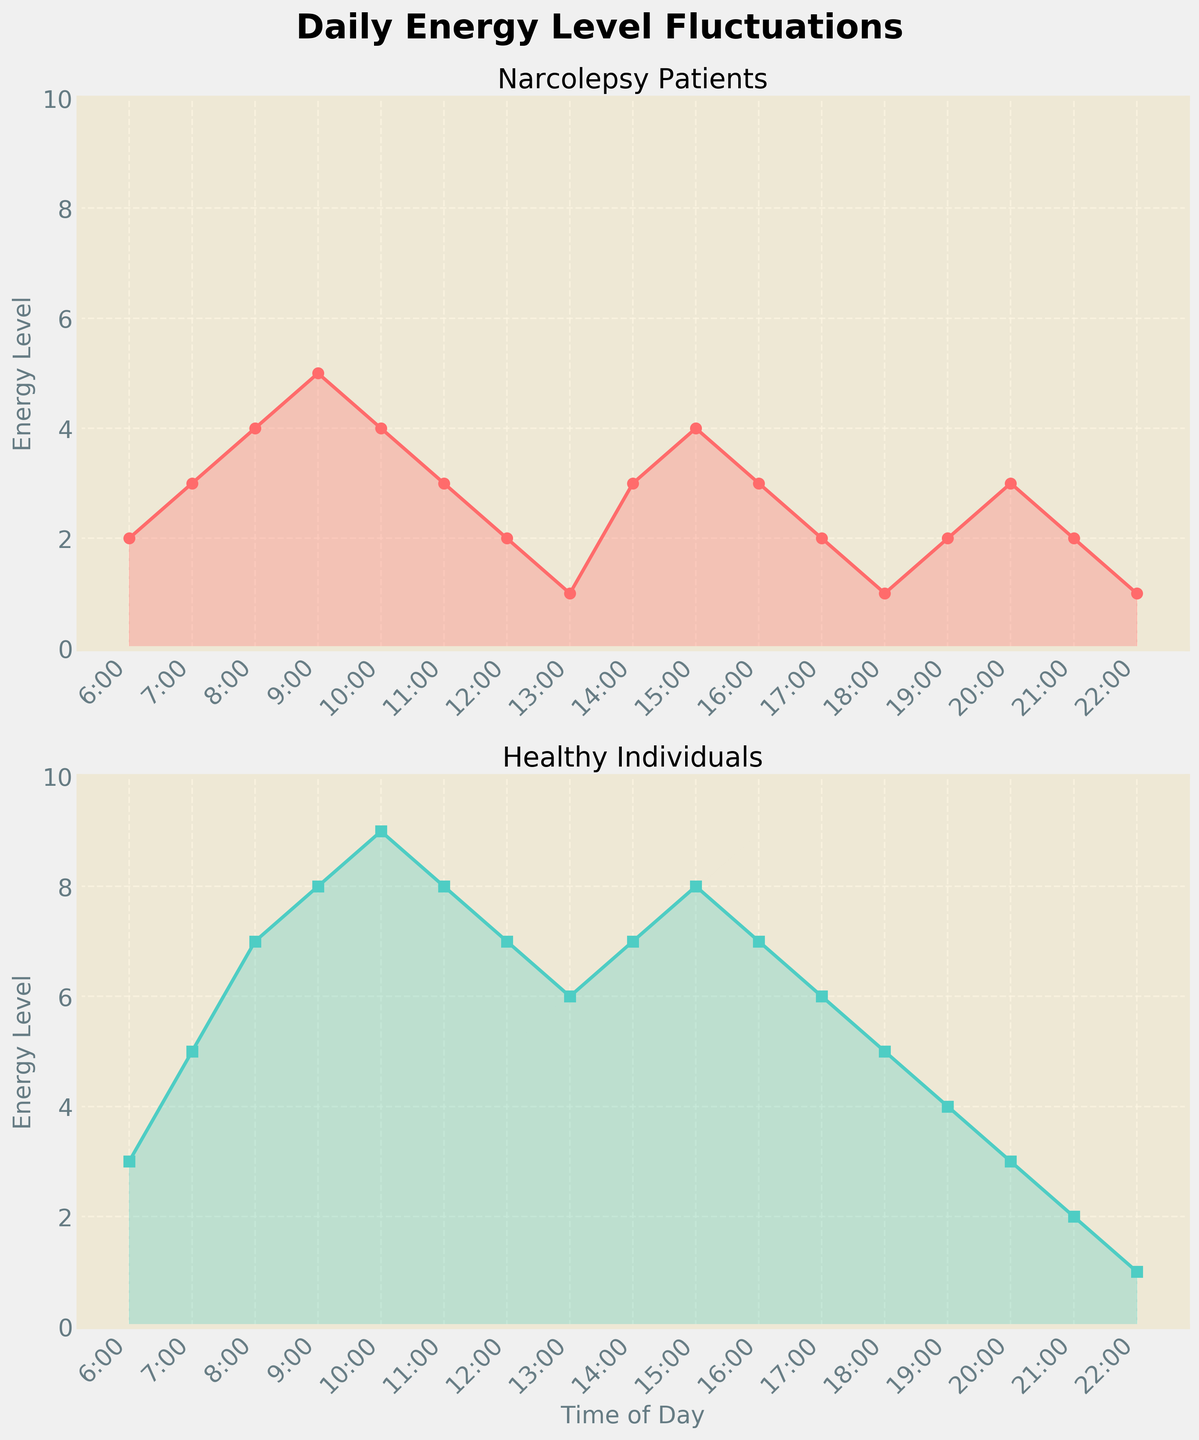What's the title of the figure? The title of the figure is displayed at the top of the plot. It is common to include a title in a plot to give an overview of what the plot is about. In this case, the title is 'Daily Energy Level Fluctuations'.
Answer: Daily Energy Level Fluctuations What are the colors of the lines representing Narcolepsy patients and Healthy individuals? The colors of the lines can be identified by observing the plot. The line for Narcolepsy patients is red, and the line for Healthy individuals is greenish-teal.
Answer: Red and greenish-teal At which time do Narcolepsy patients have the highest energy level? To find the time of the highest energy level for Narcolepsy patients, look for the peak in the red (Narcolepsy) line. The highest point occurs at 9:00.
Answer: 9:00 At what time does the energy level of both groups drop to the minimum level? Identify the lowest points in both plots and compare the times. Both groups' energy levels are at the minimum at 22:00.
Answer: 22:00 How does the overall trend of energy levels throughout the day differ between Narcolepsy patients and Healthy individuals? Compare the plots for Narcolepsy patients and Healthy individuals. Narcolepsy patients' energy levels fluctuate more and tend to drop sharply during midday, while Healthy individuals maintain higher and more stable energy levels throughout the day.
Answer: Narcolepsy patients' energy levels fluctuate more and drop sharply in midday; Healthy individuals' levels are higher and more stable What is the difference in energy levels between Narcolepsy patients and Healthy individuals at 10:00? Observe the data points for both groups at 10:00. The energy level for Narcolepsy patients is 4, while for Healthy individuals it is 9. The difference is 9 - 4 = 5.
Answer: 5 Which group has a more stable energy level throughout the day, based on the plot? Stability can be inferred from the smoothness of the curve. Healthy individuals have a smoother curve with less sharp fluctuations compared to Narcolepsy patients.
Answer: Healthy individuals At what time do Narcolepsy patients experience a significant drop in their energy level? Look for a sharp decrease in the red line representing Narcolepsy patients. A significant drop occurs from 10:00 to 13:00.
Answer: 10:00 to 13:00 Between which times do Healthy individuals reach their highest energy levels? Identify the peak area in the greenish-teal line. Healthy individuals reach their highest energy levels around 9:00 to 11:00.
Answer: 9:00 to 11:00 What is the energy level of Narcolepsy patients at 14:00 and how does it compare to their energy level at 15:00? Observe the energy levels at 14:00 and 15:00 in the plot for Narcolepsy patients (red line). The energy level at 14:00 is 3 and at 15:00 it's 4.
Answer: 14:00 (3) and 15:00 (4) 